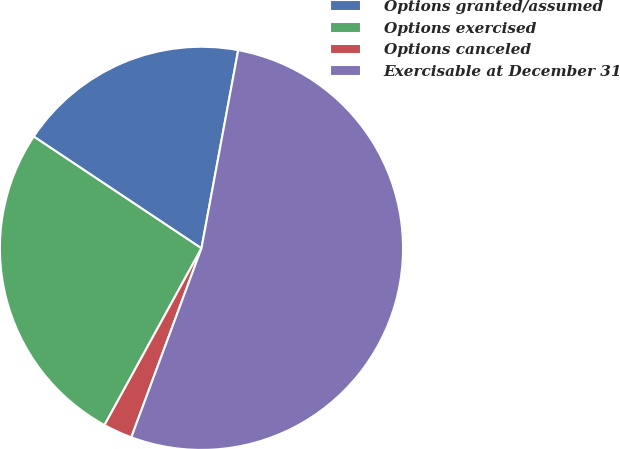Convert chart. <chart><loc_0><loc_0><loc_500><loc_500><pie_chart><fcel>Options granted/assumed<fcel>Options exercised<fcel>Options canceled<fcel>Exercisable at December 31<nl><fcel>18.56%<fcel>26.37%<fcel>2.33%<fcel>52.74%<nl></chart> 